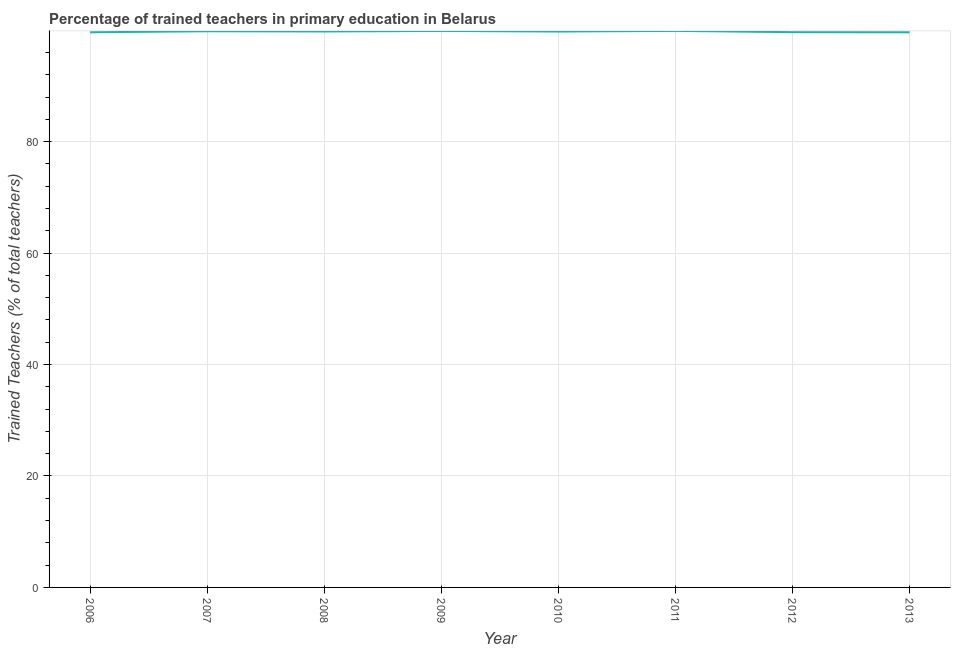What is the percentage of trained teachers in 2006?
Your answer should be compact. 99.63. Across all years, what is the maximum percentage of trained teachers?
Provide a short and direct response. 99.88. Across all years, what is the minimum percentage of trained teachers?
Your response must be concise. 99.63. In which year was the percentage of trained teachers minimum?
Make the answer very short. 2013. What is the sum of the percentage of trained teachers?
Make the answer very short. 797.99. What is the difference between the percentage of trained teachers in 2007 and 2013?
Offer a terse response. 0.18. What is the average percentage of trained teachers per year?
Your answer should be compact. 99.75. What is the median percentage of trained teachers?
Your answer should be very brief. 99.77. Do a majority of the years between 2010 and 2006 (inclusive) have percentage of trained teachers greater than 36 %?
Provide a short and direct response. Yes. What is the ratio of the percentage of trained teachers in 2007 to that in 2008?
Ensure brevity in your answer.  1. Is the percentage of trained teachers in 2009 less than that in 2013?
Ensure brevity in your answer.  No. Is the difference between the percentage of trained teachers in 2008 and 2012 greater than the difference between any two years?
Make the answer very short. No. What is the difference between the highest and the second highest percentage of trained teachers?
Give a very brief answer. 0.01. What is the difference between the highest and the lowest percentage of trained teachers?
Provide a short and direct response. 0.25. Does the percentage of trained teachers monotonically increase over the years?
Your answer should be compact. No. How many lines are there?
Provide a short and direct response. 1. How many years are there in the graph?
Offer a terse response. 8. What is the difference between two consecutive major ticks on the Y-axis?
Offer a very short reply. 20. What is the title of the graph?
Your answer should be compact. Percentage of trained teachers in primary education in Belarus. What is the label or title of the Y-axis?
Provide a short and direct response. Trained Teachers (% of total teachers). What is the Trained Teachers (% of total teachers) in 2006?
Provide a succinct answer. 99.63. What is the Trained Teachers (% of total teachers) of 2007?
Offer a terse response. 99.81. What is the Trained Teachers (% of total teachers) in 2008?
Offer a very short reply. 99.77. What is the Trained Teachers (% of total teachers) in 2009?
Offer a terse response. 99.87. What is the Trained Teachers (% of total teachers) of 2010?
Provide a succinct answer. 99.76. What is the Trained Teachers (% of total teachers) of 2011?
Give a very brief answer. 99.88. What is the Trained Teachers (% of total teachers) of 2012?
Your answer should be very brief. 99.64. What is the Trained Teachers (% of total teachers) of 2013?
Ensure brevity in your answer.  99.63. What is the difference between the Trained Teachers (% of total teachers) in 2006 and 2007?
Your response must be concise. -0.18. What is the difference between the Trained Teachers (% of total teachers) in 2006 and 2008?
Keep it short and to the point. -0.14. What is the difference between the Trained Teachers (% of total teachers) in 2006 and 2009?
Ensure brevity in your answer.  -0.24. What is the difference between the Trained Teachers (% of total teachers) in 2006 and 2010?
Offer a terse response. -0.13. What is the difference between the Trained Teachers (% of total teachers) in 2006 and 2011?
Keep it short and to the point. -0.25. What is the difference between the Trained Teachers (% of total teachers) in 2006 and 2012?
Provide a short and direct response. -0.01. What is the difference between the Trained Teachers (% of total teachers) in 2006 and 2013?
Your response must be concise. 0. What is the difference between the Trained Teachers (% of total teachers) in 2007 and 2008?
Your answer should be very brief. 0.04. What is the difference between the Trained Teachers (% of total teachers) in 2007 and 2009?
Your answer should be compact. -0.06. What is the difference between the Trained Teachers (% of total teachers) in 2007 and 2010?
Offer a very short reply. 0.05. What is the difference between the Trained Teachers (% of total teachers) in 2007 and 2011?
Your response must be concise. -0.07. What is the difference between the Trained Teachers (% of total teachers) in 2007 and 2012?
Ensure brevity in your answer.  0.17. What is the difference between the Trained Teachers (% of total teachers) in 2007 and 2013?
Provide a succinct answer. 0.18. What is the difference between the Trained Teachers (% of total teachers) in 2008 and 2009?
Give a very brief answer. -0.09. What is the difference between the Trained Teachers (% of total teachers) in 2008 and 2010?
Give a very brief answer. 0.01. What is the difference between the Trained Teachers (% of total teachers) in 2008 and 2011?
Your response must be concise. -0.11. What is the difference between the Trained Teachers (% of total teachers) in 2008 and 2012?
Make the answer very short. 0.13. What is the difference between the Trained Teachers (% of total teachers) in 2008 and 2013?
Offer a terse response. 0.14. What is the difference between the Trained Teachers (% of total teachers) in 2009 and 2010?
Offer a terse response. 0.1. What is the difference between the Trained Teachers (% of total teachers) in 2009 and 2011?
Provide a succinct answer. -0.01. What is the difference between the Trained Teachers (% of total teachers) in 2009 and 2012?
Ensure brevity in your answer.  0.22. What is the difference between the Trained Teachers (% of total teachers) in 2009 and 2013?
Keep it short and to the point. 0.24. What is the difference between the Trained Teachers (% of total teachers) in 2010 and 2011?
Keep it short and to the point. -0.12. What is the difference between the Trained Teachers (% of total teachers) in 2010 and 2012?
Keep it short and to the point. 0.12. What is the difference between the Trained Teachers (% of total teachers) in 2010 and 2013?
Your response must be concise. 0.13. What is the difference between the Trained Teachers (% of total teachers) in 2011 and 2012?
Your answer should be compact. 0.23. What is the difference between the Trained Teachers (% of total teachers) in 2011 and 2013?
Make the answer very short. 0.25. What is the difference between the Trained Teachers (% of total teachers) in 2012 and 2013?
Provide a succinct answer. 0.02. What is the ratio of the Trained Teachers (% of total teachers) in 2006 to that in 2008?
Provide a short and direct response. 1. What is the ratio of the Trained Teachers (% of total teachers) in 2006 to that in 2010?
Keep it short and to the point. 1. What is the ratio of the Trained Teachers (% of total teachers) in 2006 to that in 2013?
Offer a very short reply. 1. What is the ratio of the Trained Teachers (% of total teachers) in 2007 to that in 2011?
Make the answer very short. 1. What is the ratio of the Trained Teachers (% of total teachers) in 2007 to that in 2012?
Your response must be concise. 1. What is the ratio of the Trained Teachers (% of total teachers) in 2008 to that in 2009?
Your response must be concise. 1. What is the ratio of the Trained Teachers (% of total teachers) in 2008 to that in 2010?
Your response must be concise. 1. What is the ratio of the Trained Teachers (% of total teachers) in 2008 to that in 2012?
Your response must be concise. 1. What is the ratio of the Trained Teachers (% of total teachers) in 2009 to that in 2010?
Your answer should be very brief. 1. What is the ratio of the Trained Teachers (% of total teachers) in 2009 to that in 2011?
Offer a very short reply. 1. What is the ratio of the Trained Teachers (% of total teachers) in 2009 to that in 2012?
Your response must be concise. 1. What is the ratio of the Trained Teachers (% of total teachers) in 2010 to that in 2011?
Provide a succinct answer. 1. What is the ratio of the Trained Teachers (% of total teachers) in 2010 to that in 2013?
Provide a succinct answer. 1. What is the ratio of the Trained Teachers (% of total teachers) in 2011 to that in 2013?
Offer a terse response. 1. 